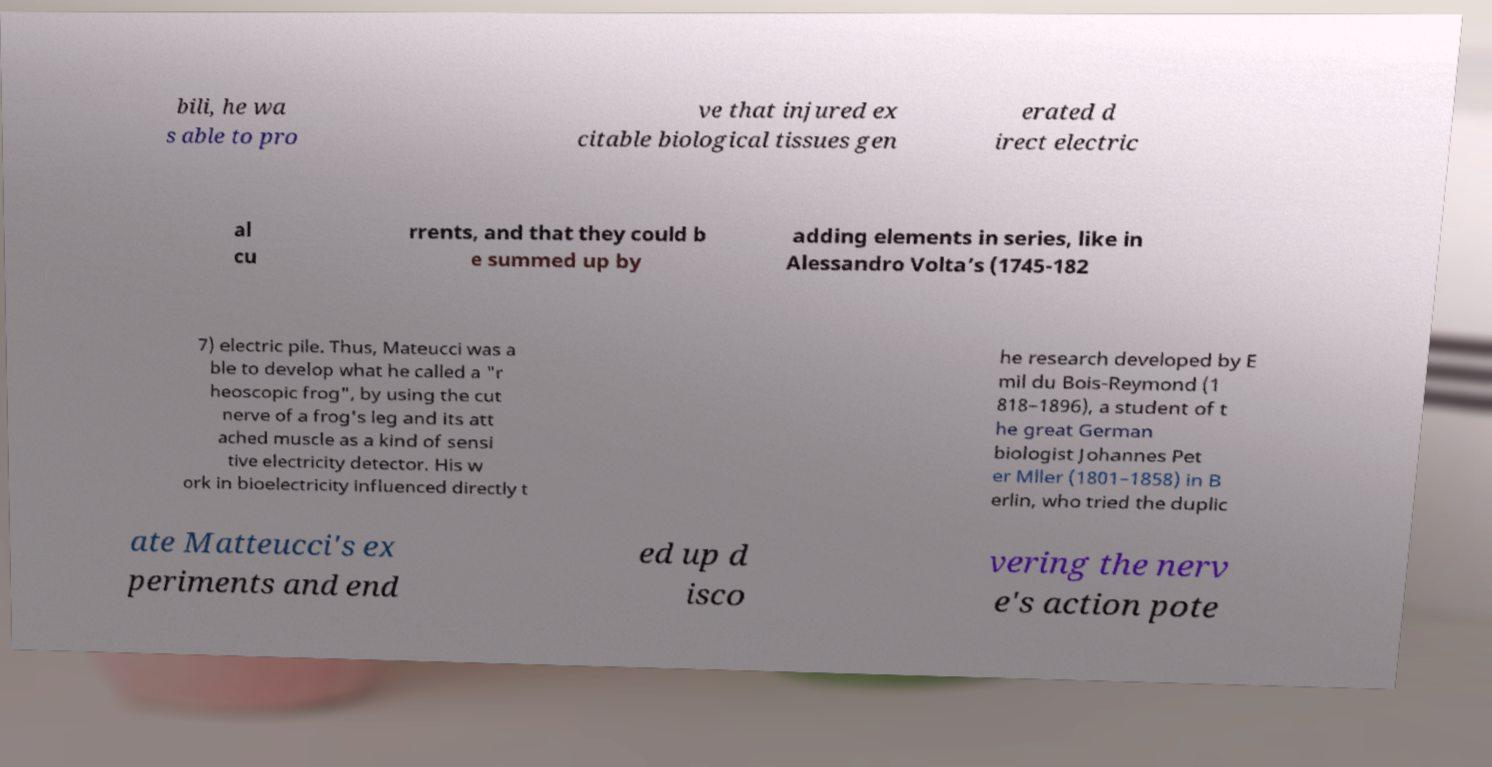For documentation purposes, I need the text within this image transcribed. Could you provide that? bili, he wa s able to pro ve that injured ex citable biological tissues gen erated d irect electric al cu rrents, and that they could b e summed up by adding elements in series, like in Alessandro Volta’s (1745-182 7) electric pile. Thus, Mateucci was a ble to develop what he called a "r heoscopic frog", by using the cut nerve of a frog's leg and its att ached muscle as a kind of sensi tive electricity detector. His w ork in bioelectricity influenced directly t he research developed by E mil du Bois-Reymond (1 818–1896), a student of t he great German biologist Johannes Pet er Mller (1801–1858) in B erlin, who tried the duplic ate Matteucci's ex periments and end ed up d isco vering the nerv e's action pote 